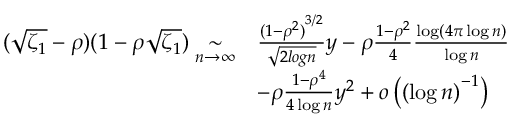Convert formula to latex. <formula><loc_0><loc_0><loc_500><loc_500>\begin{array} { r l } { ( \sqrt { \zeta _ { 1 } } - \rho ) ( 1 - \rho \sqrt { \zeta _ { 1 } } ) \underset { n \to \infty } { \sim } } & { \frac { { ( 1 - \rho ^ { 2 } ) } ^ { 3 / 2 } } { \sqrt { 2 \log n } } y - \rho \frac { 1 - \rho ^ { 2 } } { 4 } \frac { \log \left ( 4 \pi \log n \right ) } { \log n } } \\ & { - \rho \frac { 1 - \rho ^ { 4 } } { 4 \log n } y ^ { 2 } + o \left ( { ( \log n ) } ^ { - 1 } \right ) } \end{array}</formula> 